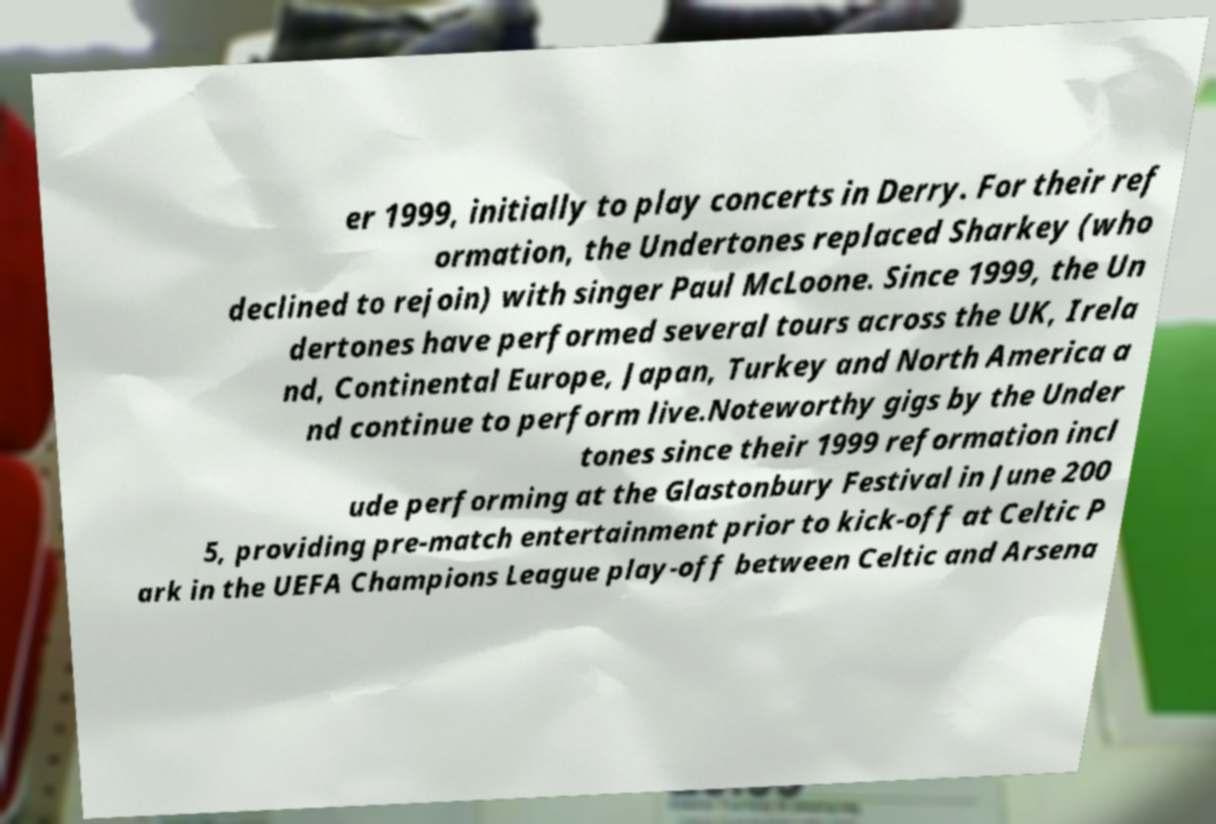Could you assist in decoding the text presented in this image and type it out clearly? er 1999, initially to play concerts in Derry. For their ref ormation, the Undertones replaced Sharkey (who declined to rejoin) with singer Paul McLoone. Since 1999, the Un dertones have performed several tours across the UK, Irela nd, Continental Europe, Japan, Turkey and North America a nd continue to perform live.Noteworthy gigs by the Under tones since their 1999 reformation incl ude performing at the Glastonbury Festival in June 200 5, providing pre-match entertainment prior to kick-off at Celtic P ark in the UEFA Champions League play-off between Celtic and Arsena 